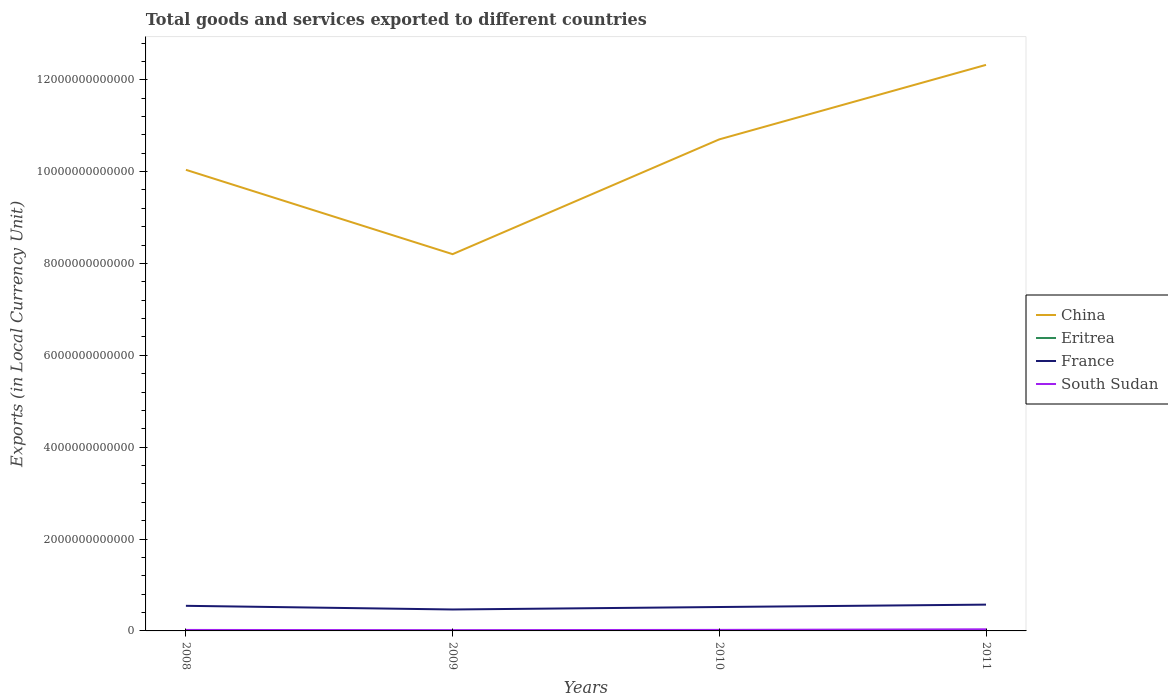Is the number of lines equal to the number of legend labels?
Ensure brevity in your answer.  Yes. Across all years, what is the maximum Amount of goods and services exports in South Sudan?
Your response must be concise. 1.70e+1. In which year was the Amount of goods and services exports in France maximum?
Provide a short and direct response. 2009. What is the total Amount of goods and services exports in South Sudan in the graph?
Your response must be concise. -7.98e+08. What is the difference between the highest and the second highest Amount of goods and services exports in South Sudan?
Your answer should be very brief. 1.82e+1. What is the difference between the highest and the lowest Amount of goods and services exports in Eritrea?
Offer a very short reply. 1. Is the Amount of goods and services exports in China strictly greater than the Amount of goods and services exports in France over the years?
Give a very brief answer. No. How many lines are there?
Make the answer very short. 4. What is the difference between two consecutive major ticks on the Y-axis?
Offer a very short reply. 2.00e+12. Does the graph contain grids?
Your answer should be compact. No. Where does the legend appear in the graph?
Provide a short and direct response. Center right. What is the title of the graph?
Your answer should be very brief. Total goods and services exported to different countries. Does "North America" appear as one of the legend labels in the graph?
Your answer should be very brief. No. What is the label or title of the Y-axis?
Your answer should be very brief. Exports (in Local Currency Unit). What is the Exports (in Local Currency Unit) of China in 2008?
Provide a short and direct response. 1.00e+13. What is the Exports (in Local Currency Unit) of Eritrea in 2008?
Your answer should be very brief. 9.40e+08. What is the Exports (in Local Currency Unit) in France in 2008?
Give a very brief answer. 5.47e+11. What is the Exports (in Local Currency Unit) in South Sudan in 2008?
Your answer should be very brief. 2.15e+1. What is the Exports (in Local Currency Unit) in China in 2009?
Your answer should be very brief. 8.20e+12. What is the Exports (in Local Currency Unit) in Eritrea in 2009?
Provide a short and direct response. 1.29e+09. What is the Exports (in Local Currency Unit) of France in 2009?
Give a very brief answer. 4.67e+11. What is the Exports (in Local Currency Unit) of South Sudan in 2009?
Keep it short and to the point. 1.70e+1. What is the Exports (in Local Currency Unit) in China in 2010?
Offer a terse response. 1.07e+13. What is the Exports (in Local Currency Unit) in Eritrea in 2010?
Your response must be concise. 1.56e+09. What is the Exports (in Local Currency Unit) in France in 2010?
Provide a short and direct response. 5.20e+11. What is the Exports (in Local Currency Unit) in South Sudan in 2010?
Give a very brief answer. 2.23e+1. What is the Exports (in Local Currency Unit) of China in 2011?
Keep it short and to the point. 1.23e+13. What is the Exports (in Local Currency Unit) of Eritrea in 2011?
Give a very brief answer. 5.76e+09. What is the Exports (in Local Currency Unit) of France in 2011?
Ensure brevity in your answer.  5.73e+11. What is the Exports (in Local Currency Unit) of South Sudan in 2011?
Keep it short and to the point. 3.52e+1. Across all years, what is the maximum Exports (in Local Currency Unit) in China?
Your response must be concise. 1.23e+13. Across all years, what is the maximum Exports (in Local Currency Unit) of Eritrea?
Make the answer very short. 5.76e+09. Across all years, what is the maximum Exports (in Local Currency Unit) in France?
Your answer should be very brief. 5.73e+11. Across all years, what is the maximum Exports (in Local Currency Unit) in South Sudan?
Give a very brief answer. 3.52e+1. Across all years, what is the minimum Exports (in Local Currency Unit) in China?
Keep it short and to the point. 8.20e+12. Across all years, what is the minimum Exports (in Local Currency Unit) of Eritrea?
Your response must be concise. 9.40e+08. Across all years, what is the minimum Exports (in Local Currency Unit) of France?
Ensure brevity in your answer.  4.67e+11. Across all years, what is the minimum Exports (in Local Currency Unit) of South Sudan?
Offer a very short reply. 1.70e+1. What is the total Exports (in Local Currency Unit) of China in the graph?
Provide a succinct answer. 4.13e+13. What is the total Exports (in Local Currency Unit) of Eritrea in the graph?
Provide a succinct answer. 9.56e+09. What is the total Exports (in Local Currency Unit) in France in the graph?
Offer a very short reply. 2.11e+12. What is the total Exports (in Local Currency Unit) in South Sudan in the graph?
Keep it short and to the point. 9.60e+1. What is the difference between the Exports (in Local Currency Unit) of China in 2008 and that in 2009?
Give a very brief answer. 1.84e+12. What is the difference between the Exports (in Local Currency Unit) of Eritrea in 2008 and that in 2009?
Make the answer very short. -3.53e+08. What is the difference between the Exports (in Local Currency Unit) in France in 2008 and that in 2009?
Provide a short and direct response. 7.98e+1. What is the difference between the Exports (in Local Currency Unit) in South Sudan in 2008 and that in 2009?
Your response must be concise. 4.43e+09. What is the difference between the Exports (in Local Currency Unit) of China in 2008 and that in 2010?
Keep it short and to the point. -6.63e+11. What is the difference between the Exports (in Local Currency Unit) in Eritrea in 2008 and that in 2010?
Your response must be concise. -6.19e+08. What is the difference between the Exports (in Local Currency Unit) of France in 2008 and that in 2010?
Offer a terse response. 2.61e+1. What is the difference between the Exports (in Local Currency Unit) in South Sudan in 2008 and that in 2010?
Your answer should be compact. -7.98e+08. What is the difference between the Exports (in Local Currency Unit) in China in 2008 and that in 2011?
Make the answer very short. -2.28e+12. What is the difference between the Exports (in Local Currency Unit) of Eritrea in 2008 and that in 2011?
Offer a terse response. -4.82e+09. What is the difference between the Exports (in Local Currency Unit) of France in 2008 and that in 2011?
Keep it short and to the point. -2.60e+1. What is the difference between the Exports (in Local Currency Unit) of South Sudan in 2008 and that in 2011?
Your response must be concise. -1.37e+1. What is the difference between the Exports (in Local Currency Unit) in China in 2009 and that in 2010?
Ensure brevity in your answer.  -2.50e+12. What is the difference between the Exports (in Local Currency Unit) in Eritrea in 2009 and that in 2010?
Your response must be concise. -2.66e+08. What is the difference between the Exports (in Local Currency Unit) in France in 2009 and that in 2010?
Keep it short and to the point. -5.37e+1. What is the difference between the Exports (in Local Currency Unit) of South Sudan in 2009 and that in 2010?
Give a very brief answer. -5.23e+09. What is the difference between the Exports (in Local Currency Unit) in China in 2009 and that in 2011?
Your answer should be compact. -4.12e+12. What is the difference between the Exports (in Local Currency Unit) in Eritrea in 2009 and that in 2011?
Give a very brief answer. -4.47e+09. What is the difference between the Exports (in Local Currency Unit) of France in 2009 and that in 2011?
Your answer should be compact. -1.06e+11. What is the difference between the Exports (in Local Currency Unit) in South Sudan in 2009 and that in 2011?
Offer a very short reply. -1.82e+1. What is the difference between the Exports (in Local Currency Unit) of China in 2010 and that in 2011?
Your answer should be compact. -1.62e+12. What is the difference between the Exports (in Local Currency Unit) of Eritrea in 2010 and that in 2011?
Give a very brief answer. -4.21e+09. What is the difference between the Exports (in Local Currency Unit) in France in 2010 and that in 2011?
Give a very brief answer. -5.21e+1. What is the difference between the Exports (in Local Currency Unit) in South Sudan in 2010 and that in 2011?
Your response must be concise. -1.29e+1. What is the difference between the Exports (in Local Currency Unit) in China in 2008 and the Exports (in Local Currency Unit) in Eritrea in 2009?
Your answer should be compact. 1.00e+13. What is the difference between the Exports (in Local Currency Unit) in China in 2008 and the Exports (in Local Currency Unit) in France in 2009?
Make the answer very short. 9.57e+12. What is the difference between the Exports (in Local Currency Unit) in China in 2008 and the Exports (in Local Currency Unit) in South Sudan in 2009?
Provide a short and direct response. 1.00e+13. What is the difference between the Exports (in Local Currency Unit) in Eritrea in 2008 and the Exports (in Local Currency Unit) in France in 2009?
Give a very brief answer. -4.66e+11. What is the difference between the Exports (in Local Currency Unit) of Eritrea in 2008 and the Exports (in Local Currency Unit) of South Sudan in 2009?
Keep it short and to the point. -1.61e+1. What is the difference between the Exports (in Local Currency Unit) of France in 2008 and the Exports (in Local Currency Unit) of South Sudan in 2009?
Provide a short and direct response. 5.30e+11. What is the difference between the Exports (in Local Currency Unit) in China in 2008 and the Exports (in Local Currency Unit) in Eritrea in 2010?
Ensure brevity in your answer.  1.00e+13. What is the difference between the Exports (in Local Currency Unit) in China in 2008 and the Exports (in Local Currency Unit) in France in 2010?
Provide a succinct answer. 9.52e+12. What is the difference between the Exports (in Local Currency Unit) of China in 2008 and the Exports (in Local Currency Unit) of South Sudan in 2010?
Your answer should be very brief. 1.00e+13. What is the difference between the Exports (in Local Currency Unit) of Eritrea in 2008 and the Exports (in Local Currency Unit) of France in 2010?
Your answer should be very brief. -5.20e+11. What is the difference between the Exports (in Local Currency Unit) of Eritrea in 2008 and the Exports (in Local Currency Unit) of South Sudan in 2010?
Your answer should be compact. -2.13e+1. What is the difference between the Exports (in Local Currency Unit) of France in 2008 and the Exports (in Local Currency Unit) of South Sudan in 2010?
Give a very brief answer. 5.24e+11. What is the difference between the Exports (in Local Currency Unit) in China in 2008 and the Exports (in Local Currency Unit) in Eritrea in 2011?
Provide a succinct answer. 1.00e+13. What is the difference between the Exports (in Local Currency Unit) in China in 2008 and the Exports (in Local Currency Unit) in France in 2011?
Your answer should be very brief. 9.47e+12. What is the difference between the Exports (in Local Currency Unit) of China in 2008 and the Exports (in Local Currency Unit) of South Sudan in 2011?
Offer a terse response. 1.00e+13. What is the difference between the Exports (in Local Currency Unit) in Eritrea in 2008 and the Exports (in Local Currency Unit) in France in 2011?
Provide a succinct answer. -5.72e+11. What is the difference between the Exports (in Local Currency Unit) in Eritrea in 2008 and the Exports (in Local Currency Unit) in South Sudan in 2011?
Your response must be concise. -3.43e+1. What is the difference between the Exports (in Local Currency Unit) of France in 2008 and the Exports (in Local Currency Unit) of South Sudan in 2011?
Offer a very short reply. 5.11e+11. What is the difference between the Exports (in Local Currency Unit) of China in 2009 and the Exports (in Local Currency Unit) of Eritrea in 2010?
Offer a terse response. 8.20e+12. What is the difference between the Exports (in Local Currency Unit) in China in 2009 and the Exports (in Local Currency Unit) in France in 2010?
Make the answer very short. 7.68e+12. What is the difference between the Exports (in Local Currency Unit) of China in 2009 and the Exports (in Local Currency Unit) of South Sudan in 2010?
Make the answer very short. 8.18e+12. What is the difference between the Exports (in Local Currency Unit) of Eritrea in 2009 and the Exports (in Local Currency Unit) of France in 2010?
Keep it short and to the point. -5.19e+11. What is the difference between the Exports (in Local Currency Unit) in Eritrea in 2009 and the Exports (in Local Currency Unit) in South Sudan in 2010?
Offer a very short reply. -2.10e+1. What is the difference between the Exports (in Local Currency Unit) in France in 2009 and the Exports (in Local Currency Unit) in South Sudan in 2010?
Provide a short and direct response. 4.44e+11. What is the difference between the Exports (in Local Currency Unit) in China in 2009 and the Exports (in Local Currency Unit) in Eritrea in 2011?
Make the answer very short. 8.20e+12. What is the difference between the Exports (in Local Currency Unit) in China in 2009 and the Exports (in Local Currency Unit) in France in 2011?
Offer a very short reply. 7.63e+12. What is the difference between the Exports (in Local Currency Unit) of China in 2009 and the Exports (in Local Currency Unit) of South Sudan in 2011?
Your answer should be very brief. 8.17e+12. What is the difference between the Exports (in Local Currency Unit) in Eritrea in 2009 and the Exports (in Local Currency Unit) in France in 2011?
Keep it short and to the point. -5.71e+11. What is the difference between the Exports (in Local Currency Unit) of Eritrea in 2009 and the Exports (in Local Currency Unit) of South Sudan in 2011?
Offer a very short reply. -3.39e+1. What is the difference between the Exports (in Local Currency Unit) of France in 2009 and the Exports (in Local Currency Unit) of South Sudan in 2011?
Offer a very short reply. 4.32e+11. What is the difference between the Exports (in Local Currency Unit) in China in 2010 and the Exports (in Local Currency Unit) in Eritrea in 2011?
Keep it short and to the point. 1.07e+13. What is the difference between the Exports (in Local Currency Unit) in China in 2010 and the Exports (in Local Currency Unit) in France in 2011?
Keep it short and to the point. 1.01e+13. What is the difference between the Exports (in Local Currency Unit) of China in 2010 and the Exports (in Local Currency Unit) of South Sudan in 2011?
Offer a terse response. 1.07e+13. What is the difference between the Exports (in Local Currency Unit) of Eritrea in 2010 and the Exports (in Local Currency Unit) of France in 2011?
Provide a short and direct response. -5.71e+11. What is the difference between the Exports (in Local Currency Unit) of Eritrea in 2010 and the Exports (in Local Currency Unit) of South Sudan in 2011?
Provide a succinct answer. -3.36e+1. What is the difference between the Exports (in Local Currency Unit) of France in 2010 and the Exports (in Local Currency Unit) of South Sudan in 2011?
Your answer should be compact. 4.85e+11. What is the average Exports (in Local Currency Unit) in China per year?
Your answer should be compact. 1.03e+13. What is the average Exports (in Local Currency Unit) of Eritrea per year?
Offer a very short reply. 2.39e+09. What is the average Exports (in Local Currency Unit) of France per year?
Your answer should be very brief. 5.27e+11. What is the average Exports (in Local Currency Unit) of South Sudan per year?
Offer a very short reply. 2.40e+1. In the year 2008, what is the difference between the Exports (in Local Currency Unit) in China and Exports (in Local Currency Unit) in Eritrea?
Make the answer very short. 1.00e+13. In the year 2008, what is the difference between the Exports (in Local Currency Unit) in China and Exports (in Local Currency Unit) in France?
Your answer should be very brief. 9.49e+12. In the year 2008, what is the difference between the Exports (in Local Currency Unit) in China and Exports (in Local Currency Unit) in South Sudan?
Keep it short and to the point. 1.00e+13. In the year 2008, what is the difference between the Exports (in Local Currency Unit) in Eritrea and Exports (in Local Currency Unit) in France?
Provide a succinct answer. -5.46e+11. In the year 2008, what is the difference between the Exports (in Local Currency Unit) of Eritrea and Exports (in Local Currency Unit) of South Sudan?
Offer a very short reply. -2.05e+1. In the year 2008, what is the difference between the Exports (in Local Currency Unit) of France and Exports (in Local Currency Unit) of South Sudan?
Ensure brevity in your answer.  5.25e+11. In the year 2009, what is the difference between the Exports (in Local Currency Unit) in China and Exports (in Local Currency Unit) in Eritrea?
Offer a terse response. 8.20e+12. In the year 2009, what is the difference between the Exports (in Local Currency Unit) in China and Exports (in Local Currency Unit) in France?
Keep it short and to the point. 7.74e+12. In the year 2009, what is the difference between the Exports (in Local Currency Unit) in China and Exports (in Local Currency Unit) in South Sudan?
Make the answer very short. 8.19e+12. In the year 2009, what is the difference between the Exports (in Local Currency Unit) in Eritrea and Exports (in Local Currency Unit) in France?
Your answer should be compact. -4.65e+11. In the year 2009, what is the difference between the Exports (in Local Currency Unit) of Eritrea and Exports (in Local Currency Unit) of South Sudan?
Provide a short and direct response. -1.57e+1. In the year 2009, what is the difference between the Exports (in Local Currency Unit) of France and Exports (in Local Currency Unit) of South Sudan?
Keep it short and to the point. 4.50e+11. In the year 2010, what is the difference between the Exports (in Local Currency Unit) of China and Exports (in Local Currency Unit) of Eritrea?
Ensure brevity in your answer.  1.07e+13. In the year 2010, what is the difference between the Exports (in Local Currency Unit) in China and Exports (in Local Currency Unit) in France?
Keep it short and to the point. 1.02e+13. In the year 2010, what is the difference between the Exports (in Local Currency Unit) in China and Exports (in Local Currency Unit) in South Sudan?
Provide a short and direct response. 1.07e+13. In the year 2010, what is the difference between the Exports (in Local Currency Unit) of Eritrea and Exports (in Local Currency Unit) of France?
Your answer should be compact. -5.19e+11. In the year 2010, what is the difference between the Exports (in Local Currency Unit) in Eritrea and Exports (in Local Currency Unit) in South Sudan?
Your answer should be very brief. -2.07e+1. In the year 2010, what is the difference between the Exports (in Local Currency Unit) of France and Exports (in Local Currency Unit) of South Sudan?
Ensure brevity in your answer.  4.98e+11. In the year 2011, what is the difference between the Exports (in Local Currency Unit) of China and Exports (in Local Currency Unit) of Eritrea?
Give a very brief answer. 1.23e+13. In the year 2011, what is the difference between the Exports (in Local Currency Unit) in China and Exports (in Local Currency Unit) in France?
Ensure brevity in your answer.  1.18e+13. In the year 2011, what is the difference between the Exports (in Local Currency Unit) in China and Exports (in Local Currency Unit) in South Sudan?
Ensure brevity in your answer.  1.23e+13. In the year 2011, what is the difference between the Exports (in Local Currency Unit) in Eritrea and Exports (in Local Currency Unit) in France?
Your answer should be very brief. -5.67e+11. In the year 2011, what is the difference between the Exports (in Local Currency Unit) of Eritrea and Exports (in Local Currency Unit) of South Sudan?
Offer a terse response. -2.94e+1. In the year 2011, what is the difference between the Exports (in Local Currency Unit) of France and Exports (in Local Currency Unit) of South Sudan?
Offer a very short reply. 5.37e+11. What is the ratio of the Exports (in Local Currency Unit) of China in 2008 to that in 2009?
Keep it short and to the point. 1.22. What is the ratio of the Exports (in Local Currency Unit) of Eritrea in 2008 to that in 2009?
Give a very brief answer. 0.73. What is the ratio of the Exports (in Local Currency Unit) of France in 2008 to that in 2009?
Provide a short and direct response. 1.17. What is the ratio of the Exports (in Local Currency Unit) in South Sudan in 2008 to that in 2009?
Provide a succinct answer. 1.26. What is the ratio of the Exports (in Local Currency Unit) of China in 2008 to that in 2010?
Keep it short and to the point. 0.94. What is the ratio of the Exports (in Local Currency Unit) of Eritrea in 2008 to that in 2010?
Your answer should be compact. 0.6. What is the ratio of the Exports (in Local Currency Unit) of France in 2008 to that in 2010?
Provide a succinct answer. 1.05. What is the ratio of the Exports (in Local Currency Unit) of South Sudan in 2008 to that in 2010?
Your answer should be very brief. 0.96. What is the ratio of the Exports (in Local Currency Unit) of China in 2008 to that in 2011?
Provide a succinct answer. 0.81. What is the ratio of the Exports (in Local Currency Unit) in Eritrea in 2008 to that in 2011?
Your answer should be very brief. 0.16. What is the ratio of the Exports (in Local Currency Unit) of France in 2008 to that in 2011?
Give a very brief answer. 0.95. What is the ratio of the Exports (in Local Currency Unit) of South Sudan in 2008 to that in 2011?
Offer a very short reply. 0.61. What is the ratio of the Exports (in Local Currency Unit) of China in 2009 to that in 2010?
Your answer should be compact. 0.77. What is the ratio of the Exports (in Local Currency Unit) of Eritrea in 2009 to that in 2010?
Keep it short and to the point. 0.83. What is the ratio of the Exports (in Local Currency Unit) in France in 2009 to that in 2010?
Make the answer very short. 0.9. What is the ratio of the Exports (in Local Currency Unit) in South Sudan in 2009 to that in 2010?
Your answer should be very brief. 0.77. What is the ratio of the Exports (in Local Currency Unit) in China in 2009 to that in 2011?
Keep it short and to the point. 0.67. What is the ratio of the Exports (in Local Currency Unit) of Eritrea in 2009 to that in 2011?
Ensure brevity in your answer.  0.22. What is the ratio of the Exports (in Local Currency Unit) in France in 2009 to that in 2011?
Keep it short and to the point. 0.82. What is the ratio of the Exports (in Local Currency Unit) of South Sudan in 2009 to that in 2011?
Offer a terse response. 0.48. What is the ratio of the Exports (in Local Currency Unit) of China in 2010 to that in 2011?
Offer a very short reply. 0.87. What is the ratio of the Exports (in Local Currency Unit) of Eritrea in 2010 to that in 2011?
Offer a very short reply. 0.27. What is the ratio of the Exports (in Local Currency Unit) of France in 2010 to that in 2011?
Keep it short and to the point. 0.91. What is the ratio of the Exports (in Local Currency Unit) in South Sudan in 2010 to that in 2011?
Give a very brief answer. 0.63. What is the difference between the highest and the second highest Exports (in Local Currency Unit) of China?
Provide a succinct answer. 1.62e+12. What is the difference between the highest and the second highest Exports (in Local Currency Unit) of Eritrea?
Keep it short and to the point. 4.21e+09. What is the difference between the highest and the second highest Exports (in Local Currency Unit) in France?
Provide a short and direct response. 2.60e+1. What is the difference between the highest and the second highest Exports (in Local Currency Unit) of South Sudan?
Give a very brief answer. 1.29e+1. What is the difference between the highest and the lowest Exports (in Local Currency Unit) of China?
Provide a succinct answer. 4.12e+12. What is the difference between the highest and the lowest Exports (in Local Currency Unit) of Eritrea?
Offer a very short reply. 4.82e+09. What is the difference between the highest and the lowest Exports (in Local Currency Unit) in France?
Give a very brief answer. 1.06e+11. What is the difference between the highest and the lowest Exports (in Local Currency Unit) of South Sudan?
Your answer should be compact. 1.82e+1. 